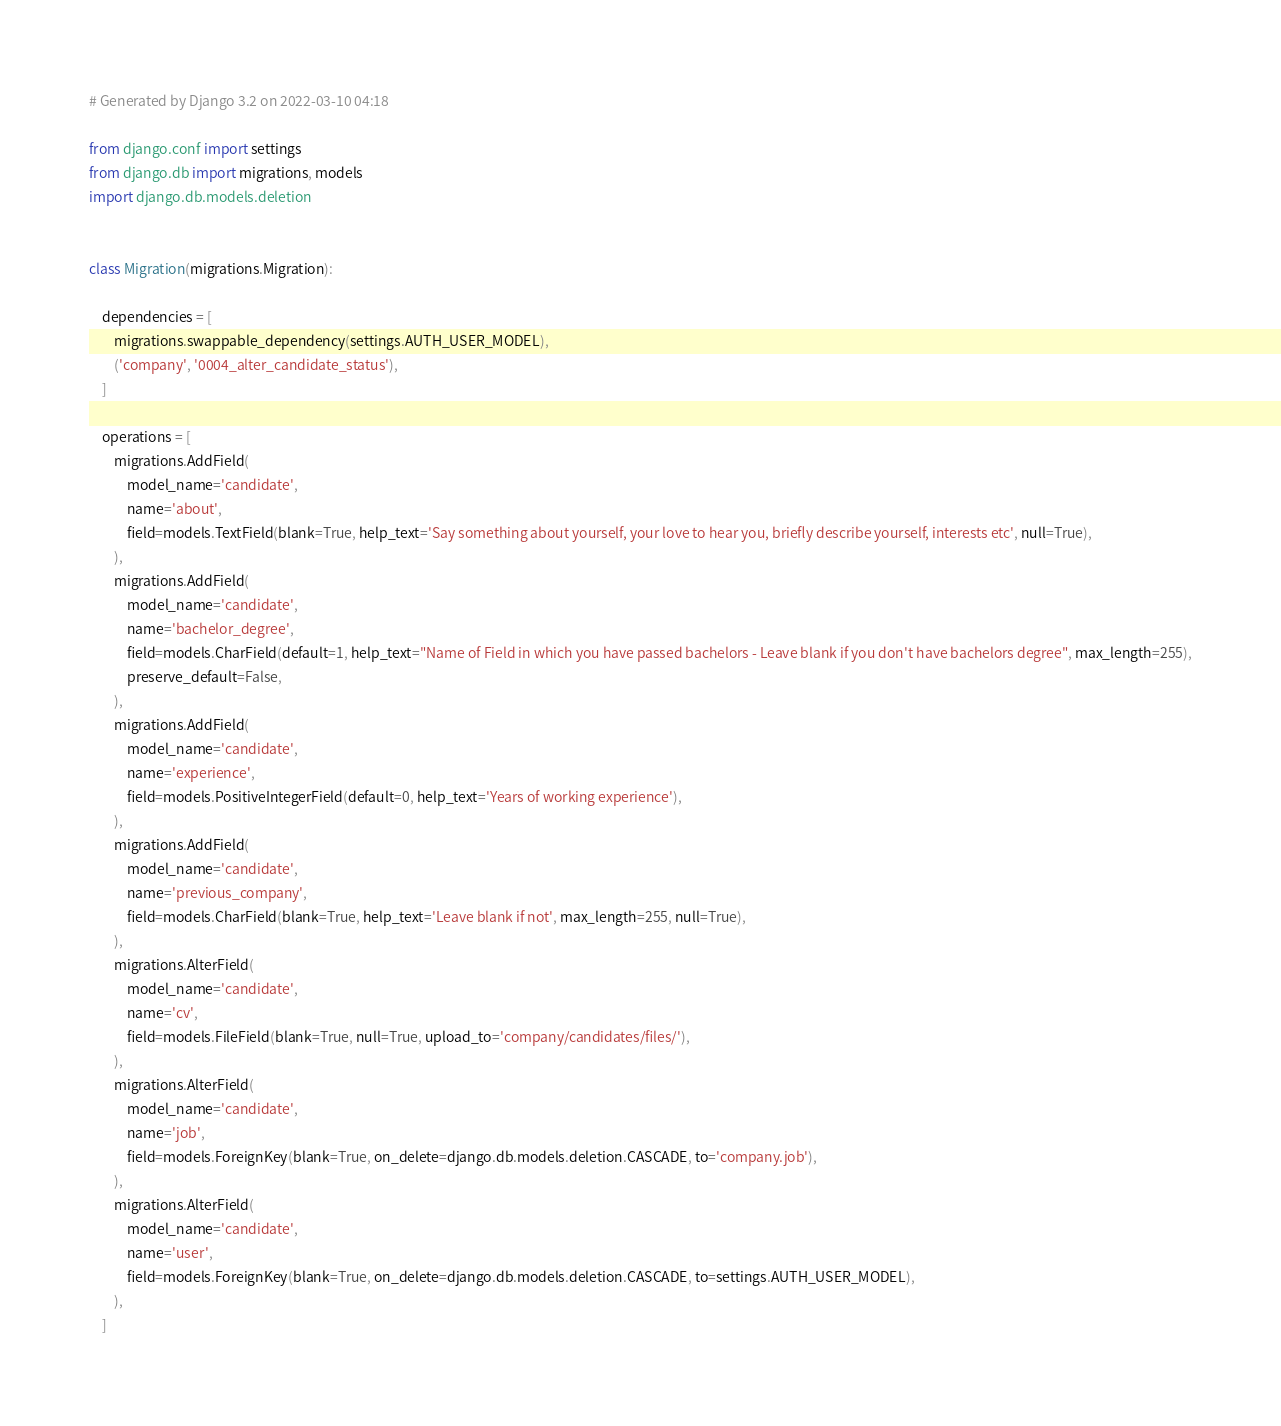Convert code to text. <code><loc_0><loc_0><loc_500><loc_500><_Python_># Generated by Django 3.2 on 2022-03-10 04:18

from django.conf import settings
from django.db import migrations, models
import django.db.models.deletion


class Migration(migrations.Migration):

    dependencies = [
        migrations.swappable_dependency(settings.AUTH_USER_MODEL),
        ('company', '0004_alter_candidate_status'),
    ]

    operations = [
        migrations.AddField(
            model_name='candidate',
            name='about',
            field=models.TextField(blank=True, help_text='Say something about yourself, your love to hear you, briefly describe yourself, interests etc', null=True),
        ),
        migrations.AddField(
            model_name='candidate',
            name='bachelor_degree',
            field=models.CharField(default=1, help_text="Name of Field in which you have passed bachelors - Leave blank if you don't have bachelors degree", max_length=255),
            preserve_default=False,
        ),
        migrations.AddField(
            model_name='candidate',
            name='experience',
            field=models.PositiveIntegerField(default=0, help_text='Years of working experience'),
        ),
        migrations.AddField(
            model_name='candidate',
            name='previous_company',
            field=models.CharField(blank=True, help_text='Leave blank if not', max_length=255, null=True),
        ),
        migrations.AlterField(
            model_name='candidate',
            name='cv',
            field=models.FileField(blank=True, null=True, upload_to='company/candidates/files/'),
        ),
        migrations.AlterField(
            model_name='candidate',
            name='job',
            field=models.ForeignKey(blank=True, on_delete=django.db.models.deletion.CASCADE, to='company.job'),
        ),
        migrations.AlterField(
            model_name='candidate',
            name='user',
            field=models.ForeignKey(blank=True, on_delete=django.db.models.deletion.CASCADE, to=settings.AUTH_USER_MODEL),
        ),
    ]
</code> 